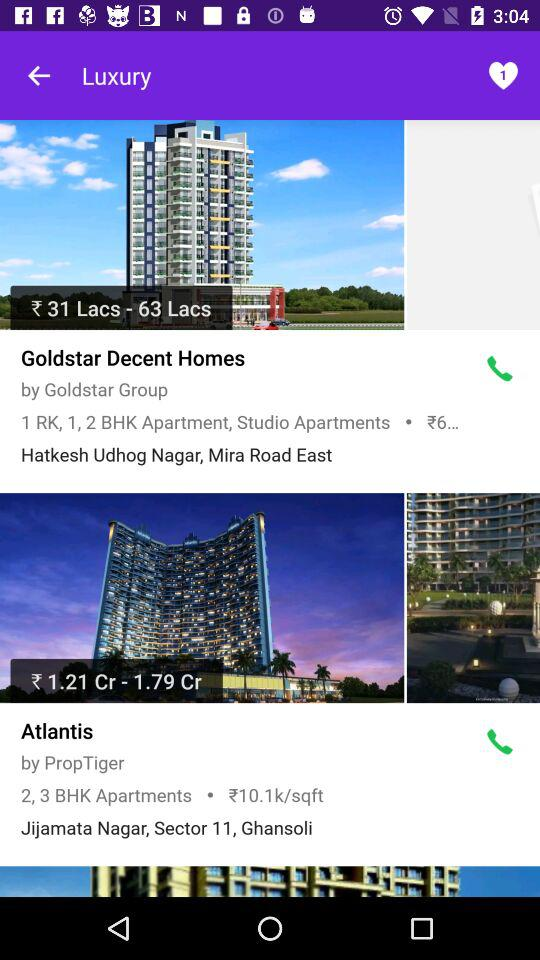What is the price per sq ft in "Atlantis"? The price is ₹10.1k/sqft. 